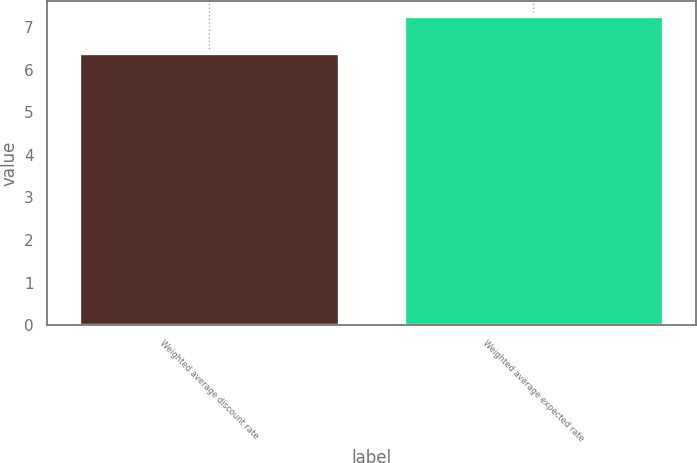Convert chart. <chart><loc_0><loc_0><loc_500><loc_500><bar_chart><fcel>Weighted average discount rate<fcel>Weighted average expected rate<nl><fcel>6.38<fcel>7.25<nl></chart> 